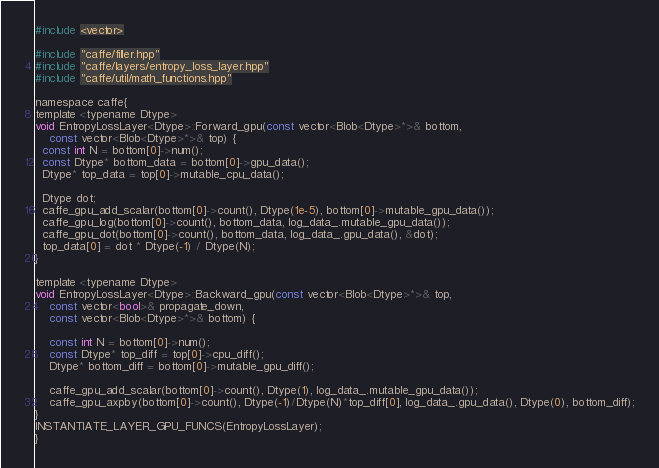<code> <loc_0><loc_0><loc_500><loc_500><_Cuda_>#include <vector>

#include "caffe/filler.hpp"
#include "caffe/layers/entropy_loss_layer.hpp"
#include "caffe/util/math_functions.hpp"

namespace caffe{
template <typename Dtype>
void EntropyLossLayer<Dtype>::Forward_gpu(const vector<Blob<Dtype>*>& bottom,
    const vector<Blob<Dtype>*>& top) {
  const int N = bottom[0]->num();
  const Dtype* bottom_data = bottom[0]->gpu_data();
  Dtype* top_data = top[0]->mutable_cpu_data();
  
  Dtype dot;
  caffe_gpu_add_scalar(bottom[0]->count(), Dtype(1e-5), bottom[0]->mutable_gpu_data());
  caffe_gpu_log(bottom[0]->count(), bottom_data, log_data_.mutable_gpu_data());
  caffe_gpu_dot(bottom[0]->count(), bottom_data, log_data_.gpu_data(), &dot);
  top_data[0] = dot * Dtype(-1) / Dtype(N);
}

template <typename Dtype>
void EntropyLossLayer<Dtype>::Backward_gpu(const vector<Blob<Dtype>*>& top,
    const vector<bool>& propagate_down,
    const vector<Blob<Dtype>*>& bottom) {
    
    const int N = bottom[0]->num();
    const Dtype* top_diff = top[0]->cpu_diff();
    Dtype* bottom_diff = bottom[0]->mutable_gpu_diff();
    
    caffe_gpu_add_scalar(bottom[0]->count(), Dtype(1), log_data_.mutable_gpu_data());
    caffe_gpu_axpby(bottom[0]->count(), Dtype(-1)/Dtype(N)*top_diff[0], log_data_.gpu_data(), Dtype(0), bottom_diff);
}
INSTANTIATE_LAYER_GPU_FUNCS(EntropyLossLayer);
}
</code> 